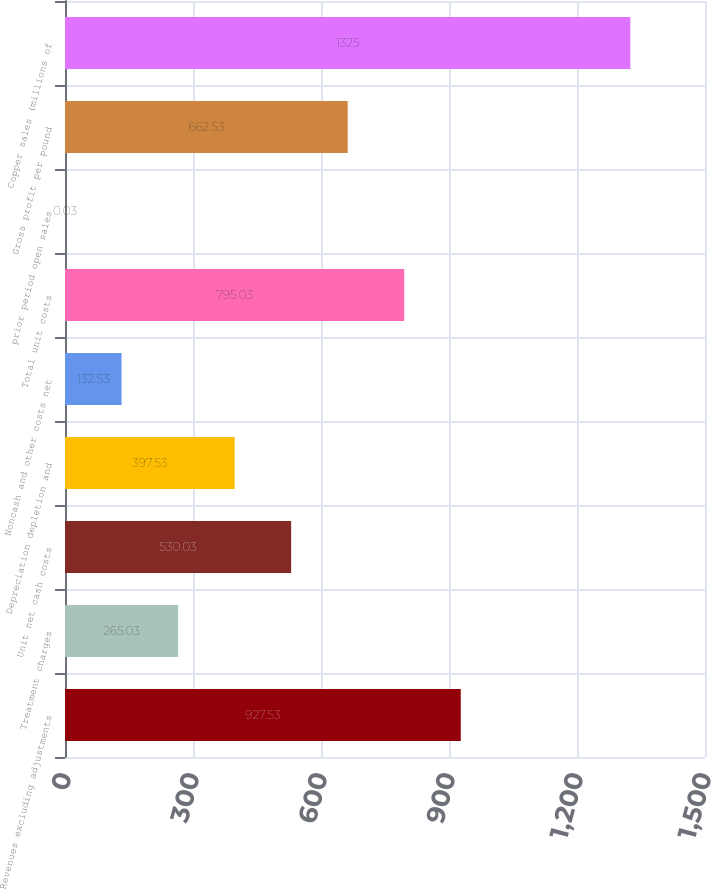<chart> <loc_0><loc_0><loc_500><loc_500><bar_chart><fcel>Revenues excluding adjustments<fcel>Treatment charges<fcel>Unit net cash costs<fcel>Depreciation depletion and<fcel>Noncash and other costs net<fcel>Total unit costs<fcel>prior period open sales<fcel>Gross profit per pound<fcel>Copper sales (millions of<nl><fcel>927.53<fcel>265.03<fcel>530.03<fcel>397.53<fcel>132.53<fcel>795.03<fcel>0.03<fcel>662.53<fcel>1325<nl></chart> 